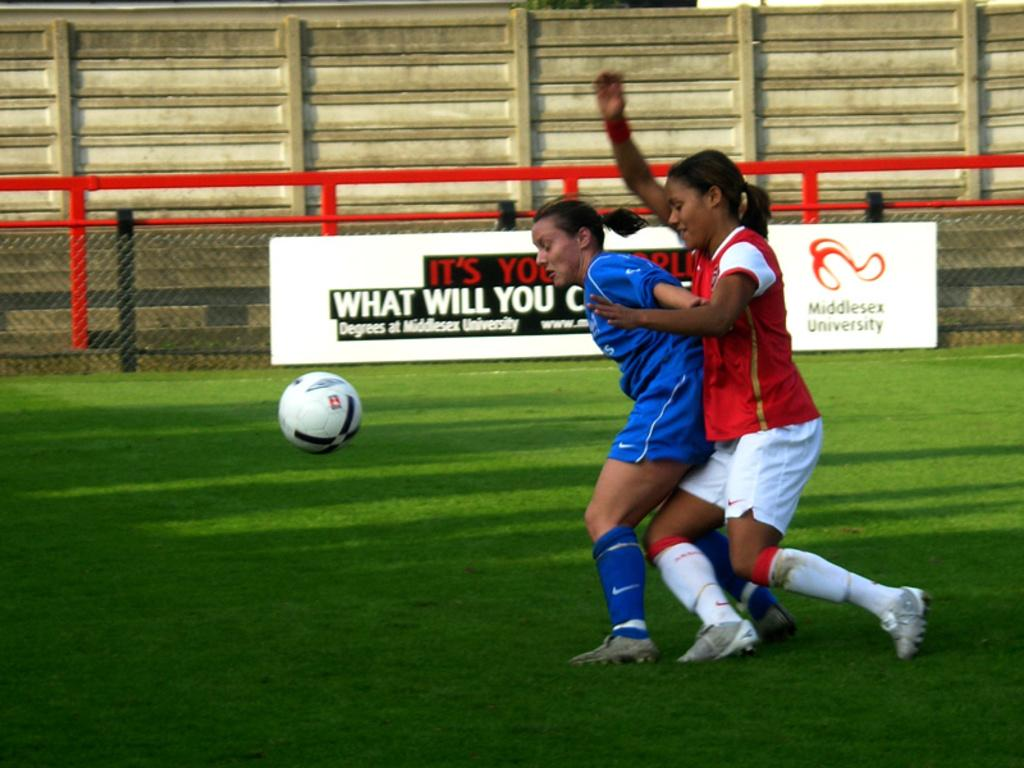How many people are in the image? There are two women in the image. What activity are the women engaged in? The women are playing football. What type of surface is visible at the bottom of the image? There is grass at the bottom of the image. What structures can be seen in the background of the image? There is a wall, a fence, and a board in the background of the image. What type of yarn is the mom using to knit during the discussion in the image? There is no mom, knitting, or discussion present in the image. 